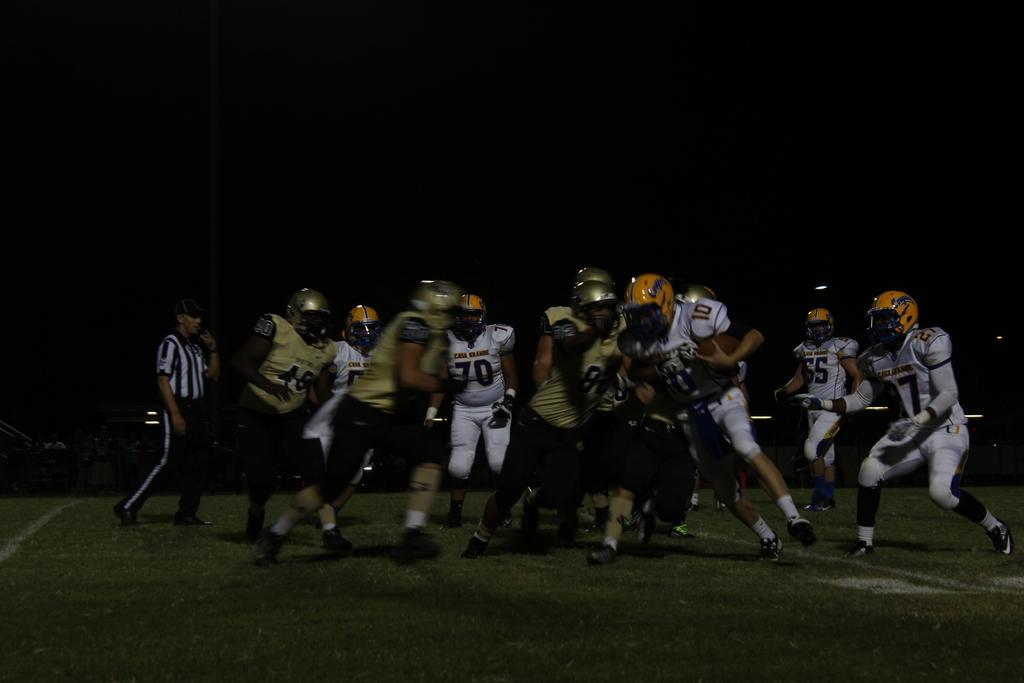What are the people in the image wearing on their heads? There are many people wearing helmets in the image. What is the person holding in the image? One person is holding a ball. Can you describe the person on the left side of the image? There is a person wearing a cap on the left side of the image. What type of surface is visible on the ground in the image? There is grass on the ground in the image. What type of alarm can be heard in the image? There is no alarm present in the image; it is a scene with people wearing helmets, one holding a ball, and a person wearing a cap on the left side, with grass on the ground. How many ducks are visible in the image? There are no ducks present in the image. 